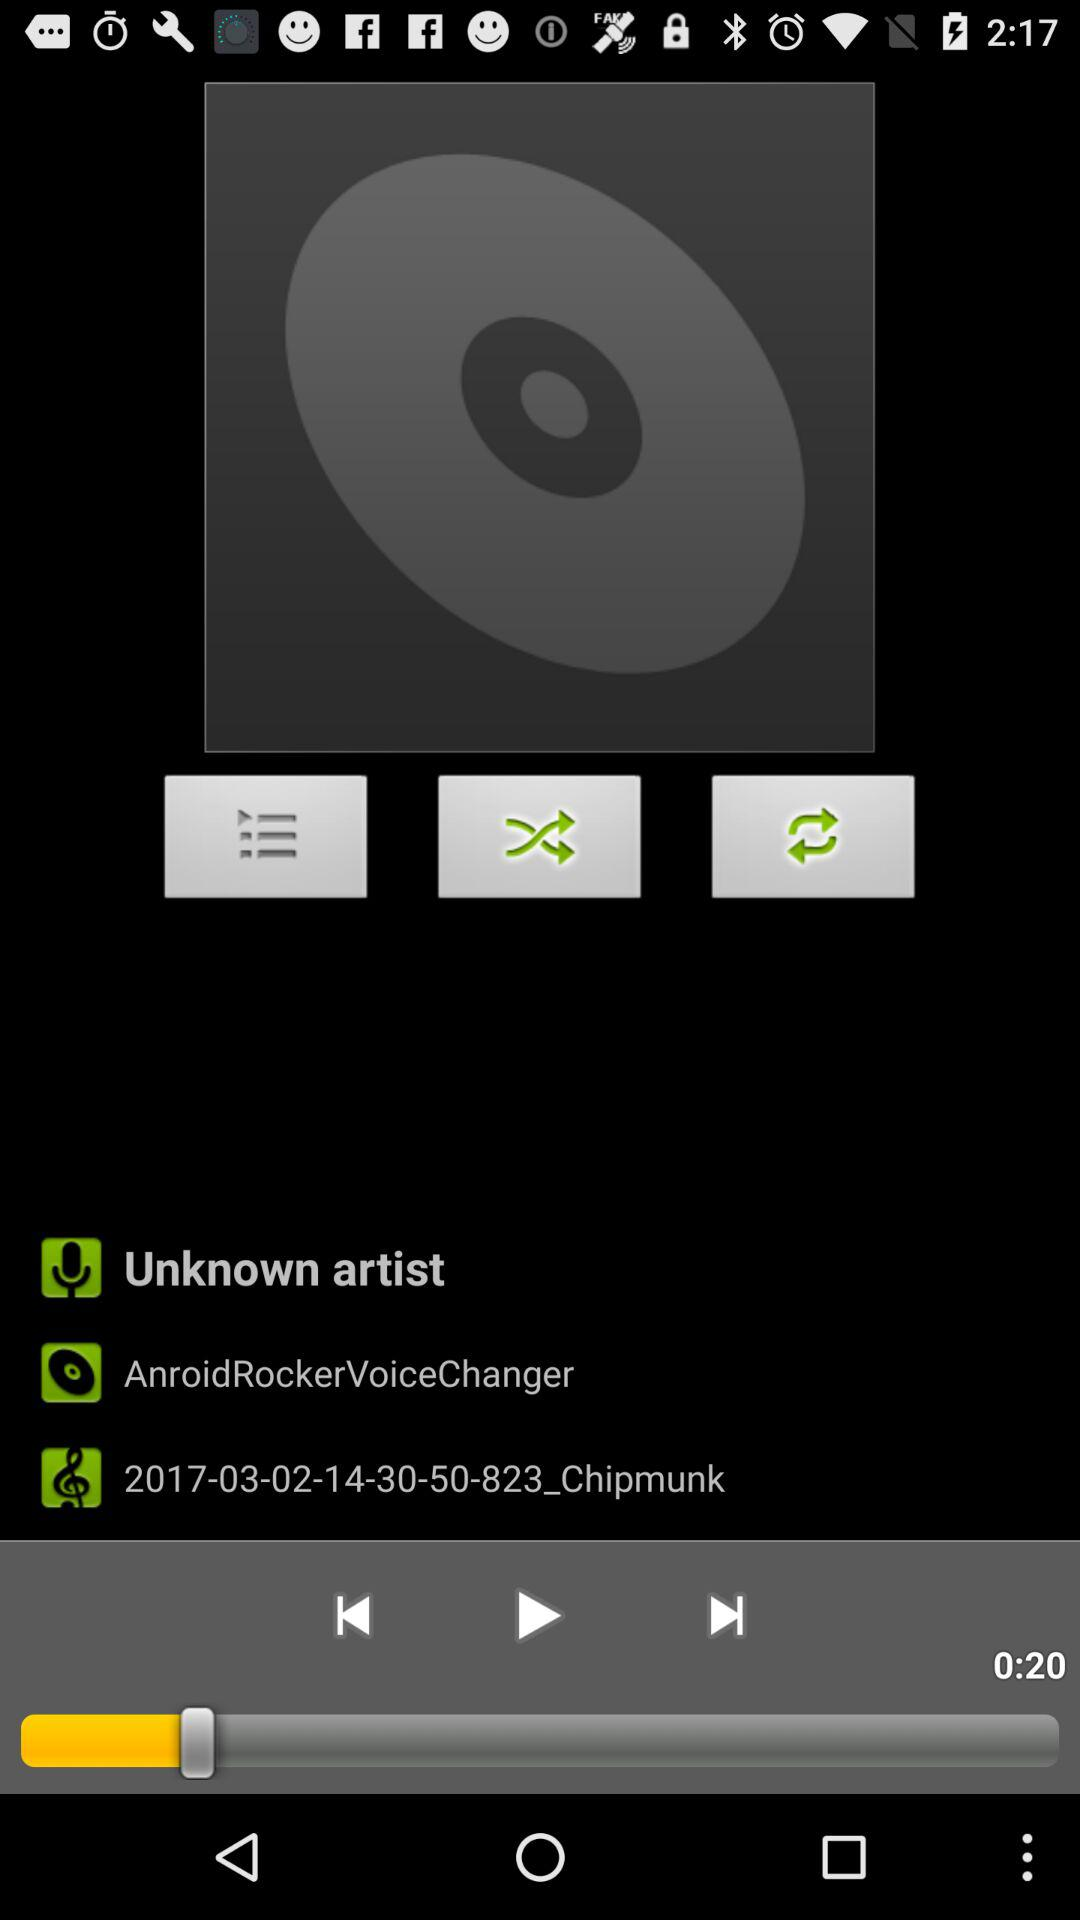How many seconds long is the current song?
Answer the question using a single word or phrase. 0:20 